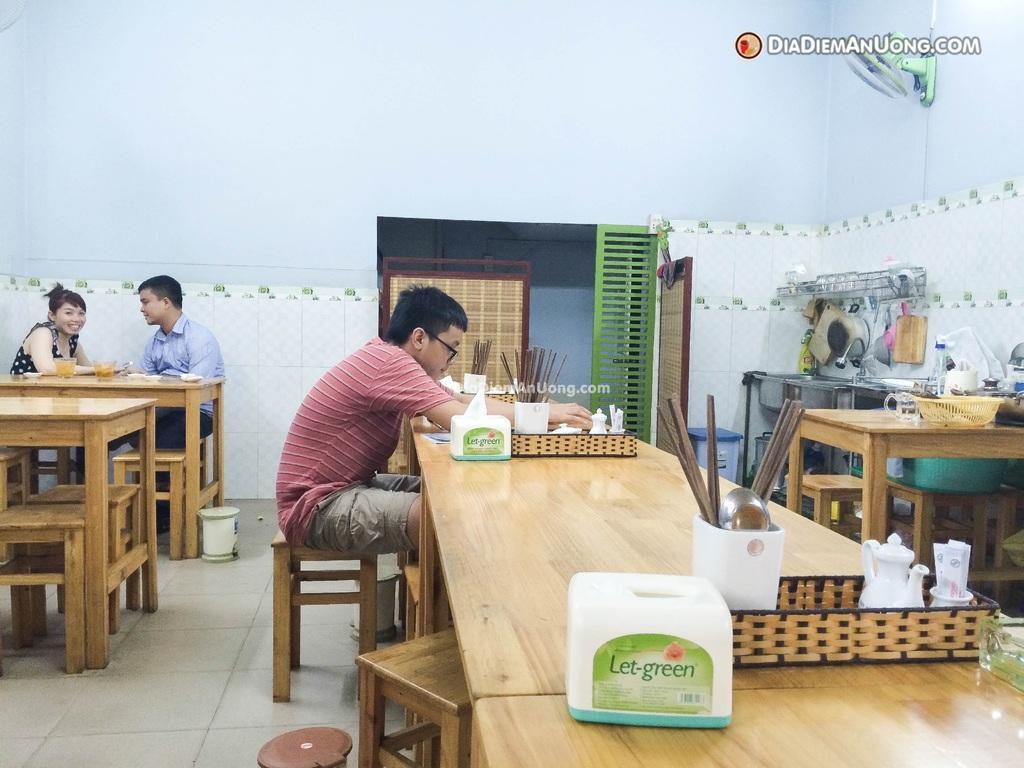In one or two sentences, can you explain what this image depicts? The person wearing the red T-shirt is sitting in a stool and there is a table in front of him, The table consists of a mug and straws and there also two person's in the left corner. 